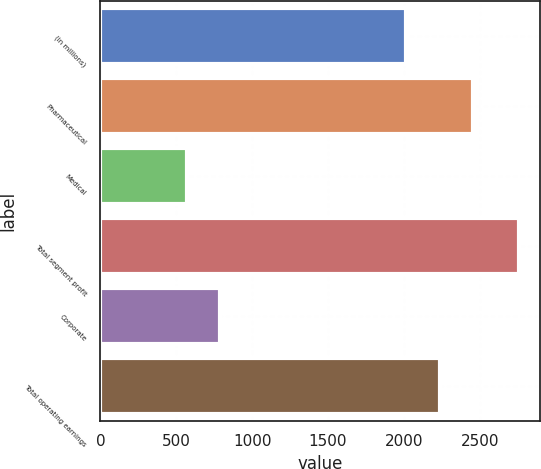Convert chart to OTSL. <chart><loc_0><loc_0><loc_500><loc_500><bar_chart><fcel>(in millions)<fcel>Pharmaceutical<fcel>Medical<fcel>Total segment profit<fcel>Corporate<fcel>Total operating earnings<nl><fcel>2017<fcel>2454.4<fcel>572<fcel>2759<fcel>790.7<fcel>2235.7<nl></chart> 